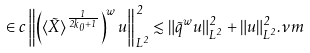Convert formula to latex. <formula><loc_0><loc_0><loc_500><loc_500>\in c \left \| \left ( \langle \tilde { X } \rangle ^ { \frac { 1 } { 2 k _ { 0 } + 1 } } \right ) ^ { w } u \right \| _ { L ^ { 2 } } ^ { 2 } \lesssim \| \tilde { q } ^ { w } u \| _ { L ^ { 2 } } ^ { 2 } + \| u \| _ { L ^ { 2 } } ^ { 2 } . \nu m</formula> 